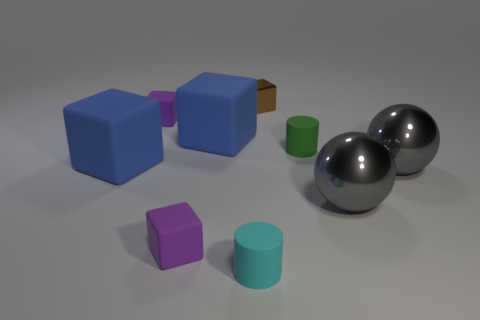Subtract all gray spheres. How many were subtracted if there are1gray spheres left? 1 Subtract all brown blocks. How many blocks are left? 4 Subtract all purple cubes. How many cubes are left? 3 Subtract 2 blue blocks. How many objects are left? 7 Subtract all blocks. How many objects are left? 4 Subtract 1 balls. How many balls are left? 1 Subtract all gray cylinders. Subtract all gray blocks. How many cylinders are left? 2 Subtract all cyan cylinders. How many red balls are left? 0 Subtract all blocks. Subtract all big metallic balls. How many objects are left? 2 Add 8 big gray things. How many big gray things are left? 10 